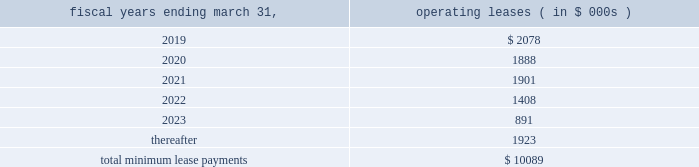Note 11 .
Commitments and contingencies commitments leases the company fffds corporate headquarters is located in danvers , massachusetts .
This facility encompasses most of the company fffds u.s .
Operations , including research and development , manufacturing , sales and marketing and general and administrative departments .
In october 2017 , the acquired its corporate headquarters for approximately $ 16.5 million and terminated its existing lease arrangement ( see note 6 ) .
Future minimum lease payments under non-cancelable leases as of march 31 , 2018 are approximately as follows : fiscal years ending march 31 , operating leases ( in $ 000s ) .
In february 2017 , the company entered into a lease agreement for an additional 21603 square feet of office space in danvers , massachusetts which expires on july 31 , 2022 .
In december 2017 , the company entered into an amendment to this lease to extend the term through august 31 , 2025 and to add an additional 6607 square feet of space in which rent would begin around june 1 , 2018 .
The amendment also allows the company a right of first offer to purchase the property from january 1 , 2018 through august 31 , 2035 , if the lessor decides to sell the building or receives an offer to purchase the building from a third-party buyer .
In march 2018 , the company entered into an amendment to the lease to add an additional 11269 square feet of space for which rent will begin on or around june 1 , 2018 through august 31 , 2025 .
The annual rent expense for this lease agreement is estimated to be $ 0.4 million .
In september 2016 , the company entered into a lease agreement in berlin , germany which commenced in may 2017 and expires in may 2024 .
The annual rent expense for the lease is estimated to be $ 0.3 million .
In october 2016 , the company entered into a lease agreement for an office in tokyokk japan and expires in september 2021 .
The office houses administrative , regulatory , and training personnel in connection with the company fffds commercial launch in japan .
The annual rent expense for the lease is estimated to be $ 0.9 million .
License agreements in april 2014 , the company entered into an exclusive license agreement for the rights to certain optical sensor technologies in the field of cardio-circulatory assist devices .
Pursuant to the terms of the license agreement , the company agreed to make potential payments of $ 6.0 million .
Through march 31 , 2018 , the company has made $ 3.5 million in milestones payments which included a $ 1.5 million upfront payment upon the execution of the agreement .
Any potential future milestone payment amounts have not been included in the contractual obligations table above due to the uncertainty related to the successful achievement of these milestones .
Contingencies from time to time , the company is involved in legal and administrative proceedings and claims of various types .
In some actions , the claimants seek damages , as well as other relief , which , if granted , would require significant expenditures .
The company records a liability in its consolidated financial statements for these matters when a loss is known or considered probable and the amount can be reasonably estimated .
The company reviews these estimates each accounting period as additional information is known and adjusts the loss provision when appropriate .
If a matter is both probable to result in liability and the amount of loss can be reasonably estimated , the company estimates and discloses the possible loss or range of loss .
If the loss is not probable or cannot be reasonably estimated , a liability is not recorded in its consolidated financial statements. .
What percent of non-cancelable future minimum lease payments are current? 
Rationale: current = due in 2019
Computations: (2078 / 10089)
Answer: 0.20597. 